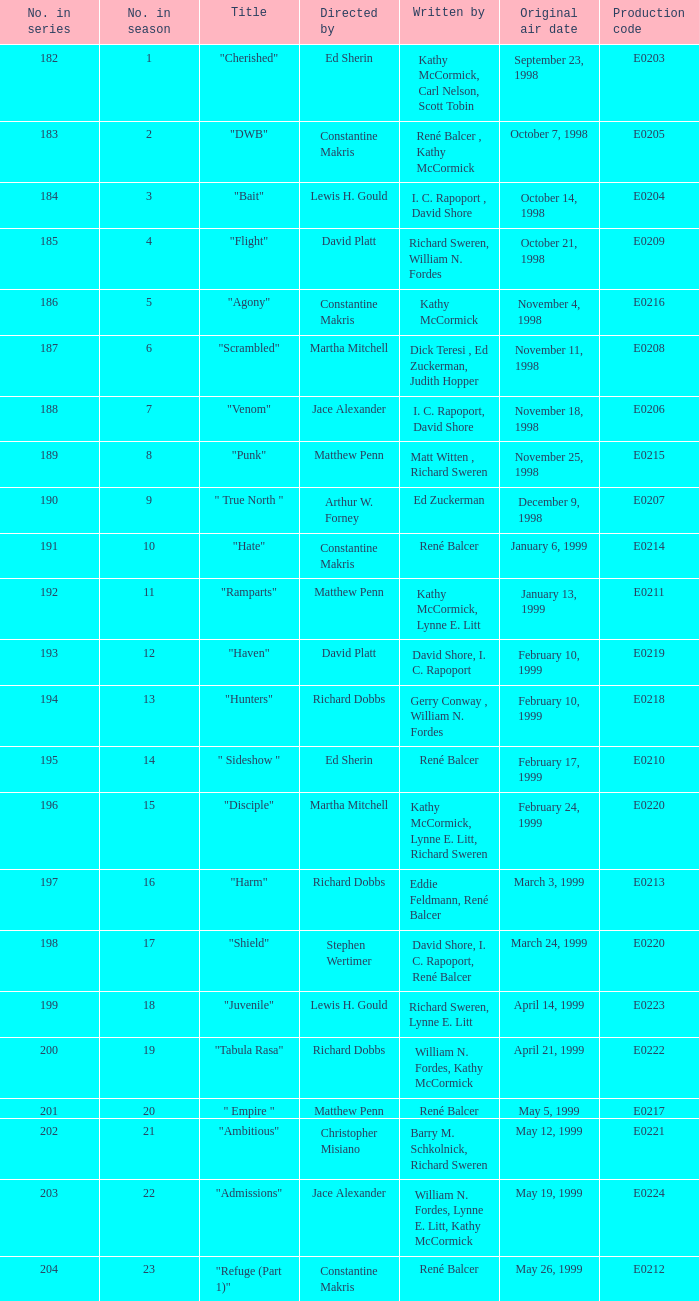On october 21, 1998, what was the title of the episode that first premiered? "Flight". 